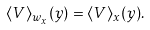<formula> <loc_0><loc_0><loc_500><loc_500>\langle V \rangle _ { w _ { x } } ( y ) = \langle V \rangle _ { x } ( y ) .</formula> 